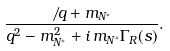<formula> <loc_0><loc_0><loc_500><loc_500>\frac { \not \, q + m _ { N ^ { * } } } { q ^ { 2 } - m _ { N ^ { * } } ^ { 2 } + i \, m _ { N ^ { * } } \Gamma _ { R } ( s ) } .</formula> 